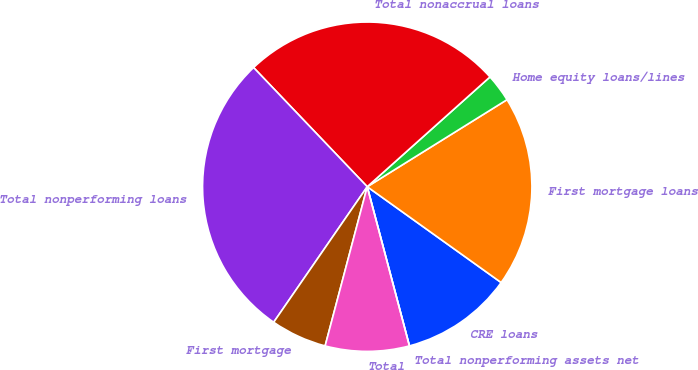<chart> <loc_0><loc_0><loc_500><loc_500><pie_chart><fcel>CRE loans<fcel>First mortgage loans<fcel>Home equity loans/lines<fcel>Total nonaccrual loans<fcel>Total nonperforming loans<fcel>First mortgage<fcel>Total<fcel>Total nonperforming assets net<nl><fcel>10.99%<fcel>18.75%<fcel>2.75%<fcel>25.51%<fcel>28.26%<fcel>5.5%<fcel>8.24%<fcel>0.0%<nl></chart> 